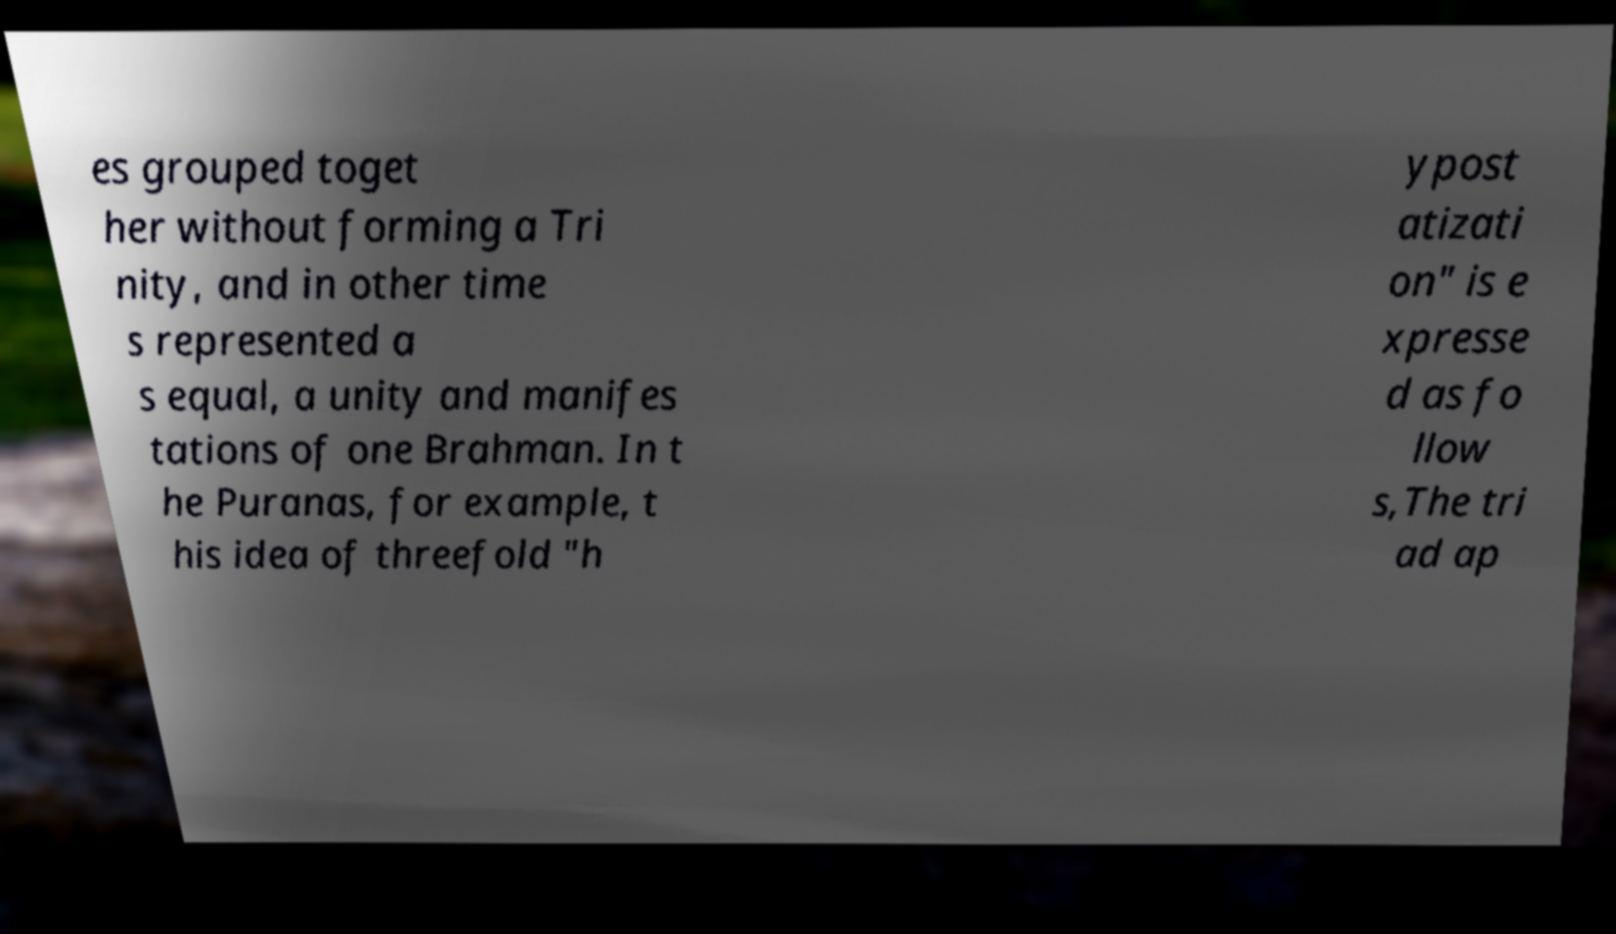Can you read and provide the text displayed in the image?This photo seems to have some interesting text. Can you extract and type it out for me? es grouped toget her without forming a Tri nity, and in other time s represented a s equal, a unity and manifes tations of one Brahman. In t he Puranas, for example, t his idea of threefold "h ypost atizati on" is e xpresse d as fo llow s,The tri ad ap 